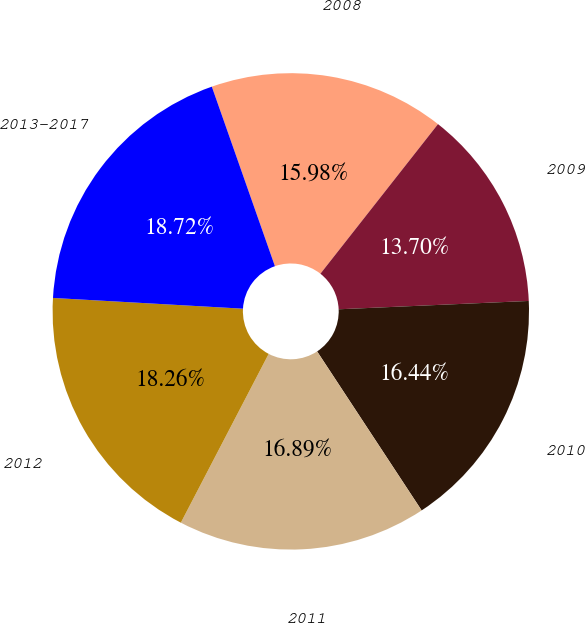Convert chart to OTSL. <chart><loc_0><loc_0><loc_500><loc_500><pie_chart><fcel>2008<fcel>2009<fcel>2010<fcel>2011<fcel>2012<fcel>2013-2017<nl><fcel>15.98%<fcel>13.7%<fcel>16.44%<fcel>16.89%<fcel>18.26%<fcel>18.72%<nl></chart> 